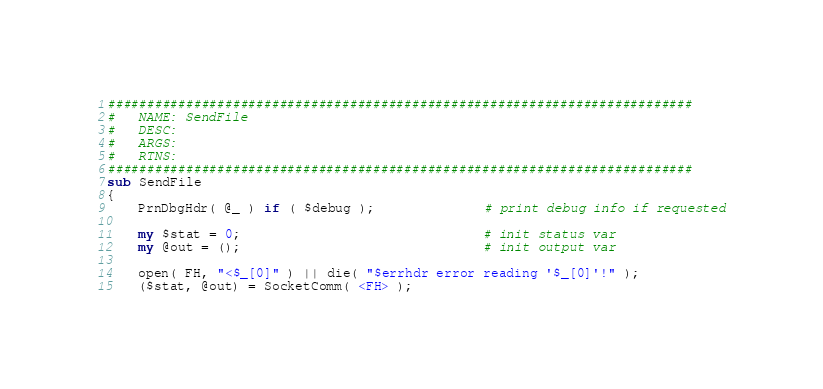Convert code to text. <code><loc_0><loc_0><loc_500><loc_500><_Perl_>
###########################################################################
#   NAME: SendFile
#   DESC: 
#   ARGS: 
#   RTNS: 
###########################################################################
sub SendFile
{
    PrnDbgHdr( @_ ) if ( $debug );              # print debug info if requested

    my $stat = 0;                               # init status var
    my @out = ();                               # init output var

    open( FH, "<$_[0]" ) || die( "$errhdr error reading '$_[0]'!" );
    ($stat, @out) = SocketComm( <FH> );</code> 